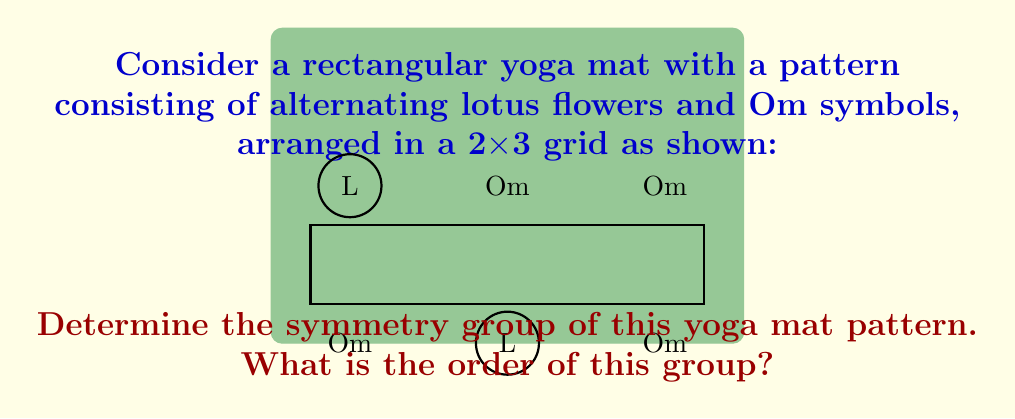Can you solve this math problem? Let's approach this step-by-step:

1) First, we need to identify all the symmetries of this pattern. The symmetries are transformations that leave the pattern unchanged.

2) Rotational symmetries:
   - 360° rotation (identity)
   - No other rotational symmetries exist

3) Reflectional symmetries:
   - Horizontal reflection through the center
   - Vertical reflection through the center

4) These symmetries form a group under composition. Let's denote:
   - $e$: identity transformation
   - $r_h$: horizontal reflection
   - $r_v$: vertical reflection

5) The group operation table:

   $$\begin{array}{c|ccc}
     & e & r_h & r_v \\
   \hline
   e & e & r_h & r_v \\
   r_h & r_h & e & r_v r_h \\
   r_v & r_v & r_v r_h & e
   \end{array}$$

6) We can see that $r_v r_h = r_h r_v$, and $(r_h)^2 = (r_v)^2 = e$

7) This group structure is isomorphic to the Klein four-group, $V_4$ or $C_2 \times C_2$

8) The order of this group is the number of elements, which is 4.
Answer: $V_4$, order 4 